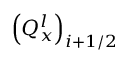Convert formula to latex. <formula><loc_0><loc_0><loc_500><loc_500>{ { \left ( Q _ { x } ^ { l } \right ) } _ { i + 1 / 2 } }</formula> 